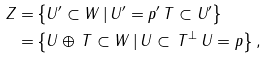Convert formula to latex. <formula><loc_0><loc_0><loc_500><loc_500>Z = & \left \{ U ^ { \prime } \subset W \, | \, U ^ { \prime } = p ^ { \prime } \, T \subset U ^ { \prime } \right \} \\ = & \left \{ U \oplus \, T \subset W \, | \, U \subset \, T ^ { \bot } \, U = p \right \} ,</formula> 